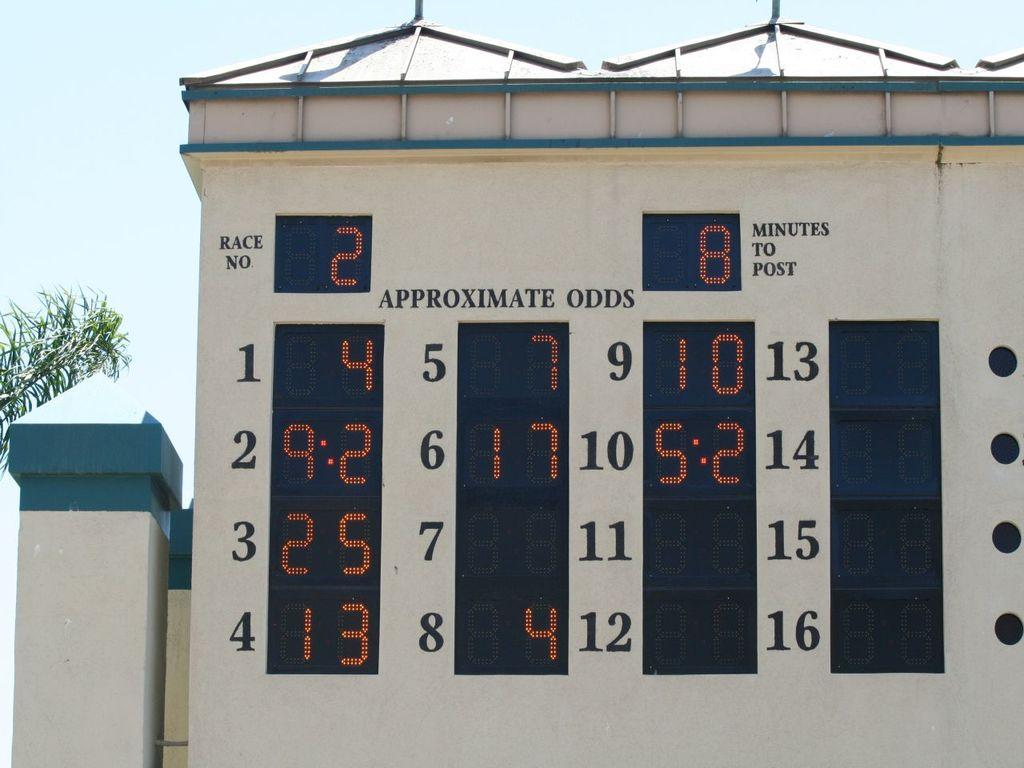<image>
Share a concise interpretation of the image provided. A sign at a race track saying that this is race number 2. 